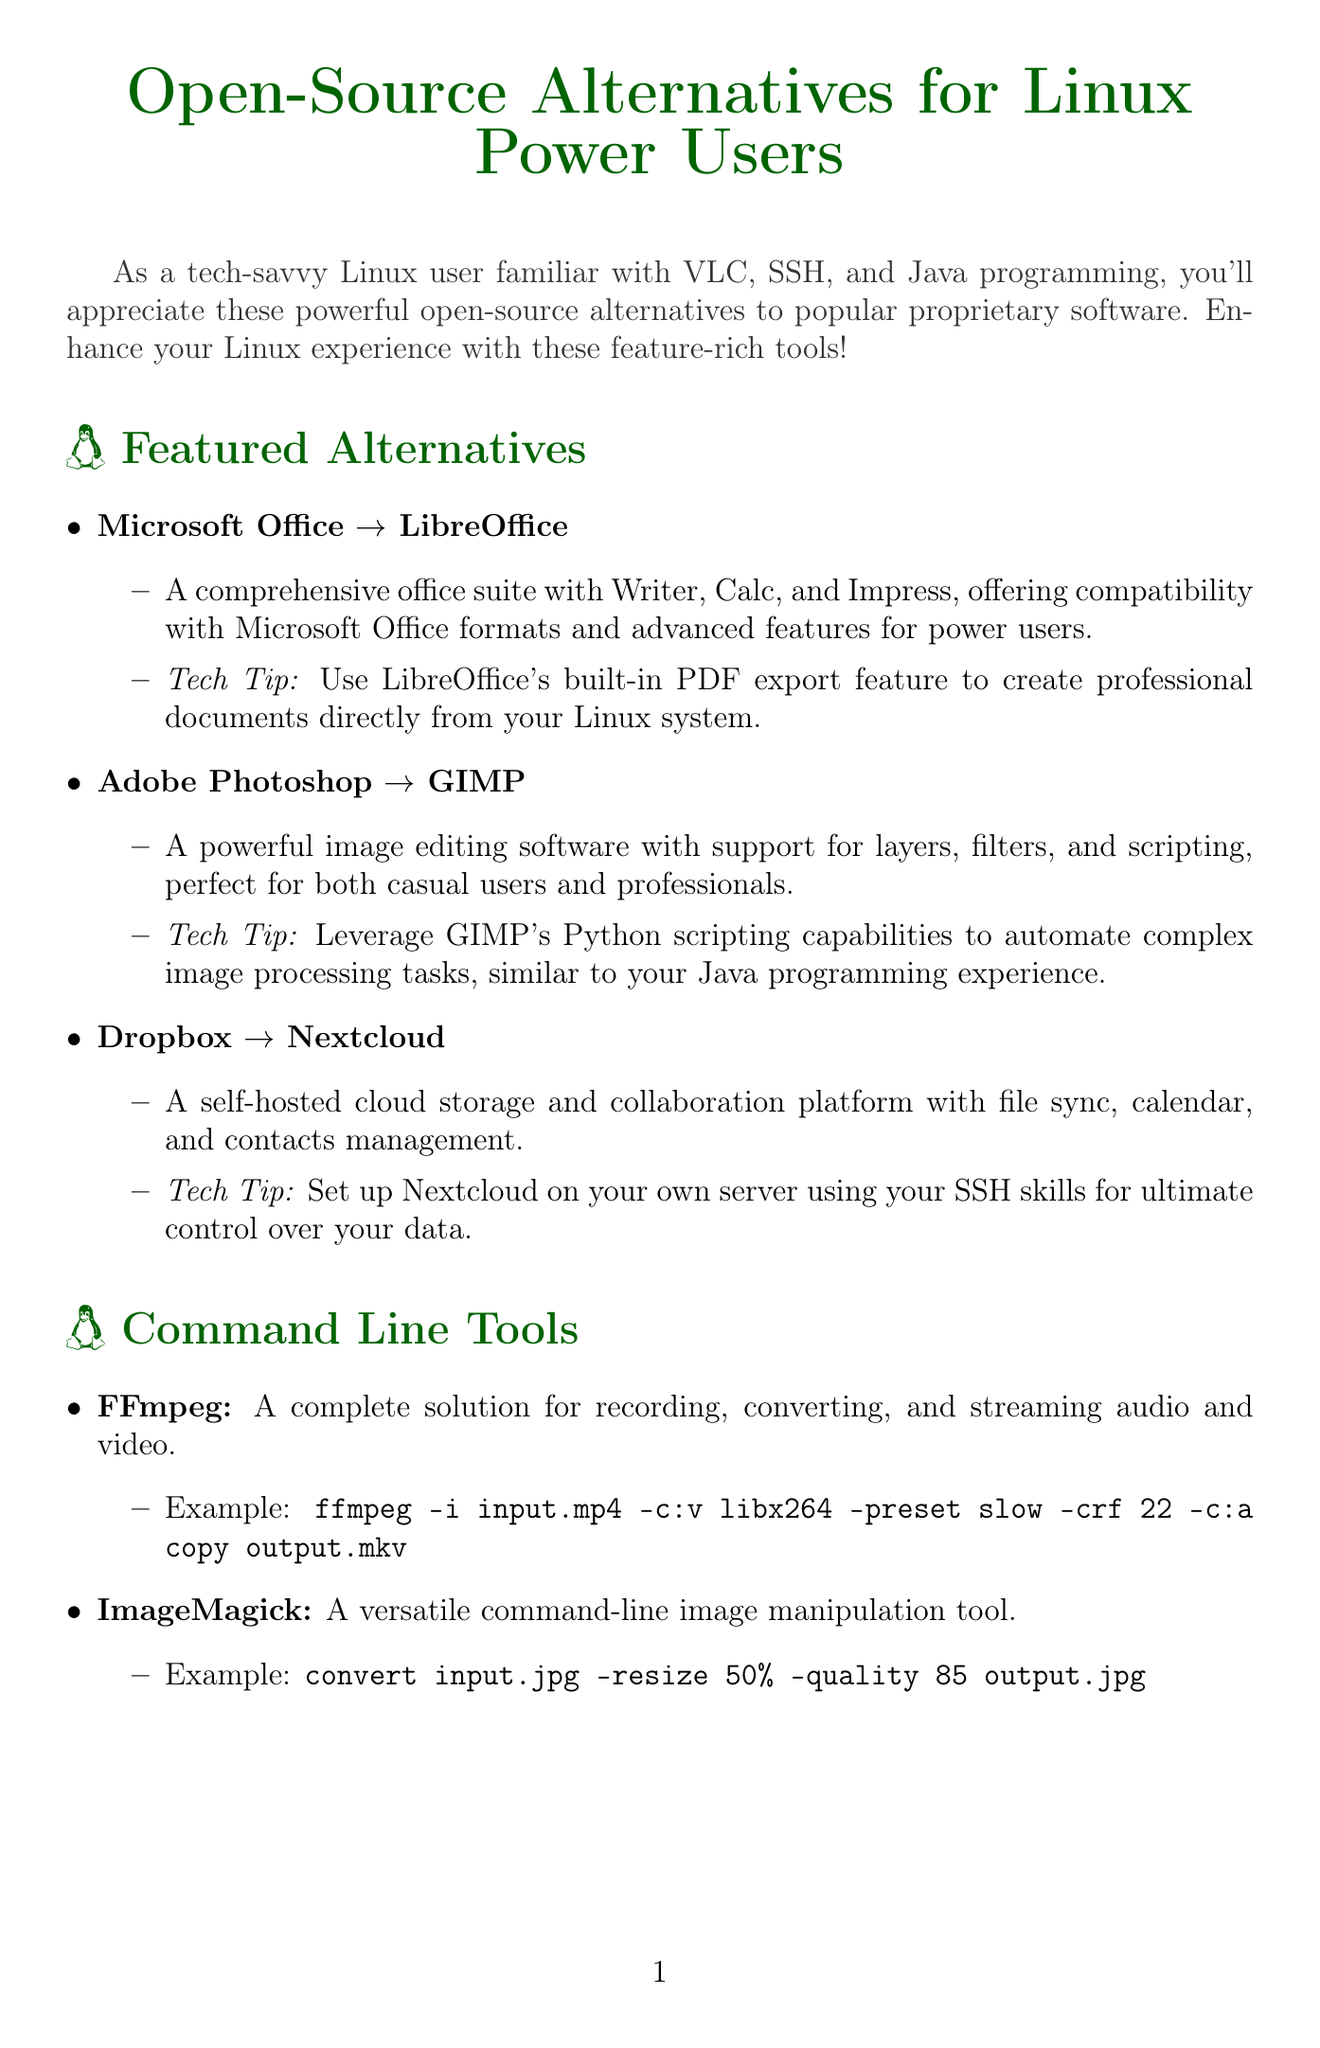what is the title of the newsletter? The title is presented at the top of the document and describes the content it covers.
Answer: Open-Source Alternatives for Linux Power Users what is the open source alternative to Microsoft Office? This information is listed under the featured alternatives section.
Answer: LibreOffice what is a key feature of Eclipse IDE? The key features of various tools are described in the programming tools section.
Answer: Extensible plugin system for customizing your development environment how many command line tools are mentioned in the newsletter? The command line tools section provides the number of tools listed.
Answer: Two what tech tip is associated with GIMP? The tech tips are provided with each featured alternative for better usability.
Answer: Leverage GIMP's Python scripting capabilities to automate complex image processing tasks which command line tool is used for audio and video processing? The document specifies the primary functionality of each command line tool listed.
Answer: FFmpeg what type of software is Nextcloud? This information is provided in the description of the open-source alternative.
Answer: Cloud storage and collaboration platform what multimedia feature does VLC support? The section on enhancing VLC discusses its functionalities for users.
Answer: Network streaming 